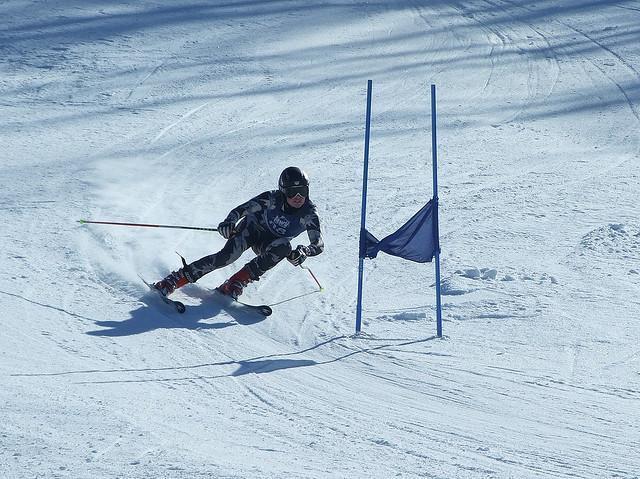How many people are in the photo?
Give a very brief answer. 1. How many orange flags are there?
Give a very brief answer. 0. 